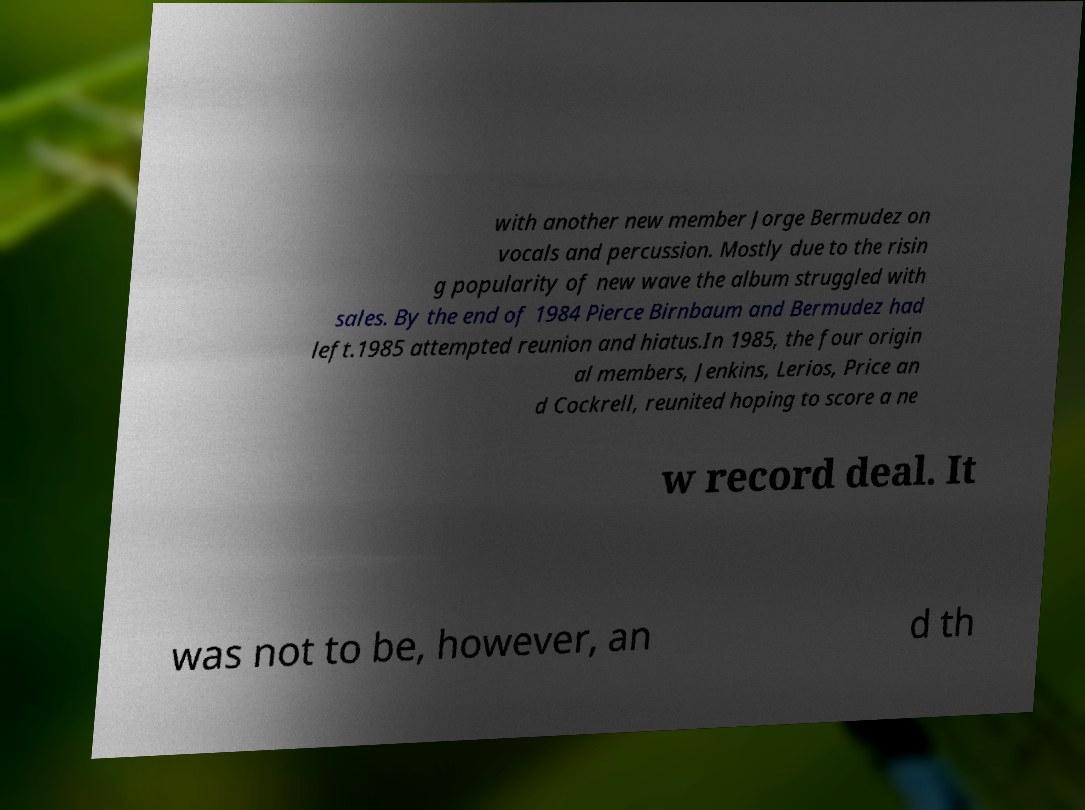There's text embedded in this image that I need extracted. Can you transcribe it verbatim? with another new member Jorge Bermudez on vocals and percussion. Mostly due to the risin g popularity of new wave the album struggled with sales. By the end of 1984 Pierce Birnbaum and Bermudez had left.1985 attempted reunion and hiatus.In 1985, the four origin al members, Jenkins, Lerios, Price an d Cockrell, reunited hoping to score a ne w record deal. It was not to be, however, an d th 